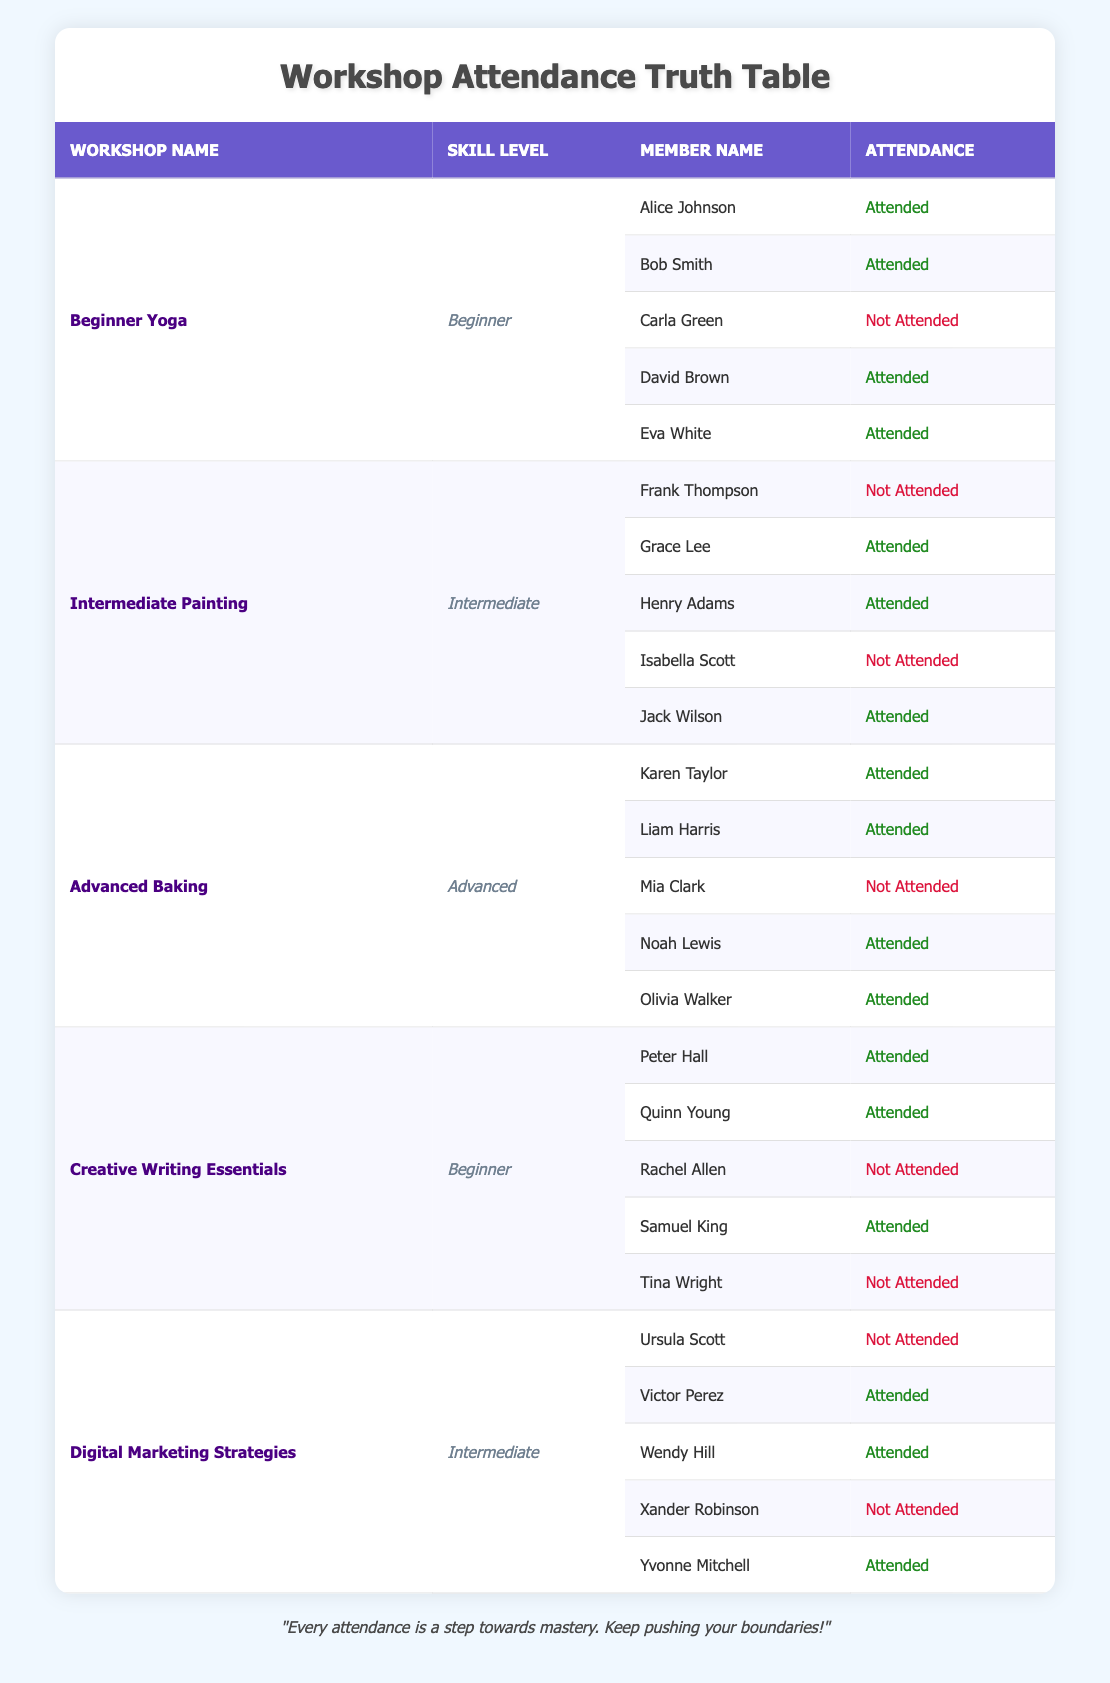What is the total number of members who attended workshops? To calculate the total attendees, we can count the 'Attended' entries across all workshops. In total, there are 3 attendees for Beginner Yoga, 3 for Intermediate Painting, 4 for Advanced Baking, 3 for Creative Writing Essentials, and 4 for Digital Marketing Strategies. Adding these numbers: 3 + 3 + 4 + 3 + 4 = 17.
Answer: 17 Which workshop had the highest attendance? By reviewing the attendance counts for each workshop, Beginner Yoga had 5 attendees, Intermediate Painting had 3, Advanced Baking had 4, Creative Writing Essentials had 3, and Digital Marketing Strategies had 4. The highest attendance is therefore 5, from the Beginner Yoga workshop.
Answer: Beginner Yoga Did any members attend both the Beginner workshops? The Beginner workshops are "Beginner Yoga" and "Creative Writing Essentials". We check the lists of attendees for both workshops and find that members Alice Johnson, David Brown, Peter Hall, and Quinn Young all attended at least one of the Beginner workshops, but none attended both as no names are repeated.
Answer: No What is the average attendance for Intermediate skill-level workshops? There are two workshops at the Intermediate level: "Intermediate Painting" and "Digital Marketing Strategies". The attendance counts for these workshops are 3 and 4, respectively. To find the average, we add the counts (3 + 4 = 7) and divide by the number of workshops (2), which gives an average of 7/2 = 3.5.
Answer: 3.5 How many members did not attend any workshop? We have a total of 20 members from all workshops and we can see that 17 members attended at least once (calculated before). The difference gives us the number of non-attendees: 20 - 17 = 3.
Answer: 3 Which member attended the most workshops? By checking each attendee's participation, Alice Johnson and David Brown attended "Beginner Yoga", while Grace Lee, Henry Adams, and Jack Wilson attended "Intermediate Painting". Karen Taylor, Liam Harris, Noah Lewis, and Olivia Walker attended "Advanced Baking". Peter Hall, Quinn Young, and Samuel King attended "Creative Writing Essentials", while Victor Perez, Wendy Hill, and Yvonne Mitchell attended "Digital Marketing Strategies". Since no individual appears in multiple workshops, the answer is each member attended only one workshop.
Answer: No member attended more than one workshop How many members did not attend the "Advanced Baking" workshop? The "Advanced Baking" workshop had 4 attendees: Karen Taylor, Liam Harris, Noah Lewis, and Olivia Walker. There are a total of 20 members; thus, the number of members who did not attend this workshop is 20 - 4 = 16.
Answer: 16 